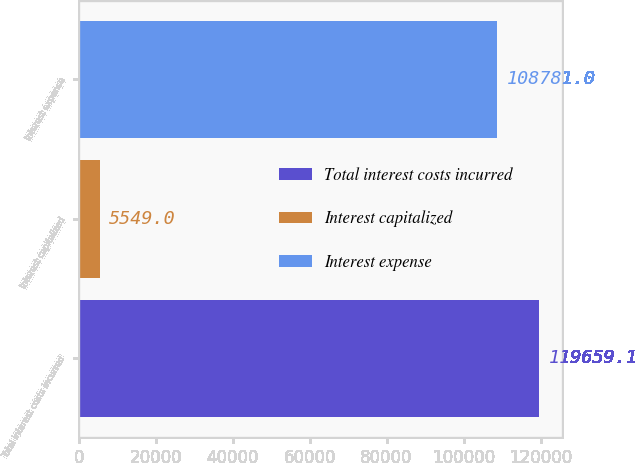<chart> <loc_0><loc_0><loc_500><loc_500><bar_chart><fcel>Total interest costs incurred<fcel>Interest capitalized<fcel>Interest expense<nl><fcel>119659<fcel>5549<fcel>108781<nl></chart> 